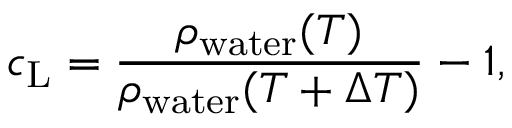Convert formula to latex. <formula><loc_0><loc_0><loc_500><loc_500>c _ { L } = \frac { \rho _ { w a t e r } ( T ) } { \rho _ { w a t e r } ( T + \Delta T ) } - 1 ,</formula> 